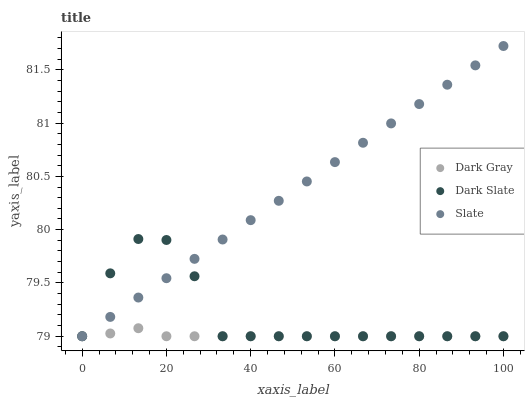Does Dark Gray have the minimum area under the curve?
Answer yes or no. Yes. Does Slate have the maximum area under the curve?
Answer yes or no. Yes. Does Dark Slate have the minimum area under the curve?
Answer yes or no. No. Does Dark Slate have the maximum area under the curve?
Answer yes or no. No. Is Slate the smoothest?
Answer yes or no. Yes. Is Dark Slate the roughest?
Answer yes or no. Yes. Is Dark Slate the smoothest?
Answer yes or no. No. Is Slate the roughest?
Answer yes or no. No. Does Dark Gray have the lowest value?
Answer yes or no. Yes. Does Slate have the highest value?
Answer yes or no. Yes. Does Dark Slate have the highest value?
Answer yes or no. No. Does Dark Slate intersect Slate?
Answer yes or no. Yes. Is Dark Slate less than Slate?
Answer yes or no. No. Is Dark Slate greater than Slate?
Answer yes or no. No. 